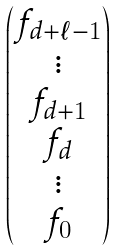<formula> <loc_0><loc_0><loc_500><loc_500>\begin{pmatrix} f _ { d + \ell - 1 } \\ \vdots \\ f _ { d + 1 } \\ f _ { d } \\ \vdots \\ f _ { 0 } \end{pmatrix}</formula> 